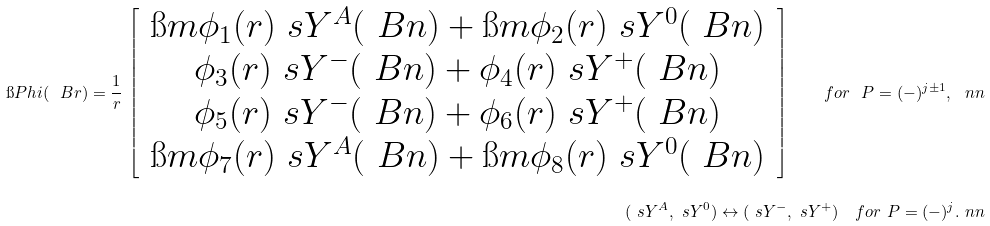<formula> <loc_0><loc_0><loc_500><loc_500>\i P h i ( \ B r ) = \frac { 1 } { r } \, \left [ \, \begin{array} { c } \i m \phi _ { 1 } ( r ) \ s Y ^ { A } ( \ B n ) + \i m \phi _ { 2 } ( r ) \ s Y ^ { 0 } ( \ B n ) \\ \phi _ { 3 } ( r ) \ s Y ^ { - } ( \ B n ) + \phi _ { 4 } ( r ) \ s Y ^ { + } ( \ B n ) \\ \phi _ { 5 } ( r ) \ s Y ^ { - } ( \ B n ) + \phi _ { 6 } ( r ) \ s Y ^ { + } ( \ B n ) \\ \i m \phi _ { 7 } ( r ) \ s Y ^ { A } ( \ B n ) + \i m \phi _ { 8 } ( r ) \ s Y ^ { 0 } ( \ B n ) \end{array} \, \right ] \quad f o r \ P = ( - ) ^ { j \pm 1 } , \ n n \\ ( \ s Y ^ { A } , \ s Y ^ { 0 } ) \leftrightarrow ( \ s Y ^ { - } , \ s Y ^ { + } ) \quad f o r \ P = ( - ) ^ { j } . \ n n</formula> 